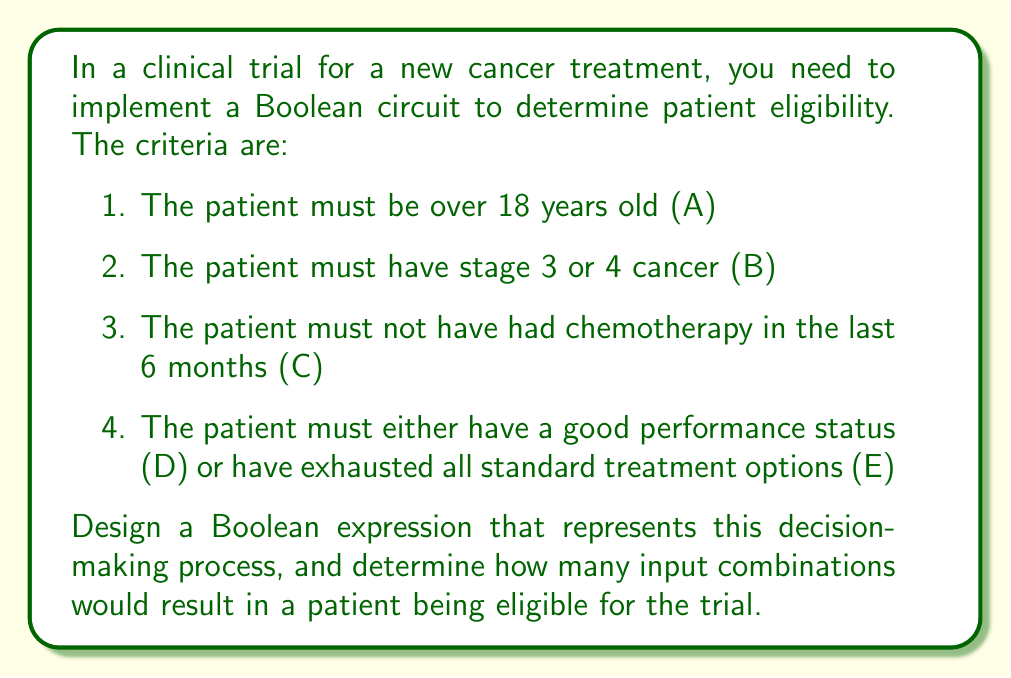Could you help me with this problem? Let's approach this step-by-step:

1) First, we need to translate the criteria into a Boolean expression:
   $$(A \land B \land C) \land (D \lor E)$$

2) This expression has 5 inputs (A, B, C, D, E), each of which can be either true (1) or false (0).

3) To find how many input combinations result in eligibility, we need to count the number of combinations where the expression evaluates to true.

4) We can use a truth table to evaluate this, but with 5 inputs, there are $2^5 = 32$ possible combinations. Instead, let's break it down:

   - $(A \land B \land C)$ must be true for the patient to be eligible.
   - Either D or E (or both) must also be true.

5) For $(A \land B \land C)$ to be true, all three inputs must be true. There's only one way for this to happen.

6) Given that $(A \land B \land C)$ is true, we now consider $(D \lor E)$:
   - D can be true and E can be false
   - D can be false and E can be true
   - Both D and E can be true

7) This gives us 3 possible combinations where the entire expression is true.

Therefore, out of the 32 possible input combinations, only 3 result in patient eligibility.
Answer: 3 